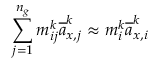Convert formula to latex. <formula><loc_0><loc_0><loc_500><loc_500>\sum _ { j = 1 } ^ { n _ { g } } m _ { i j } ^ { k } \overline { a } _ { x , j } ^ { k } \approx m _ { i } ^ { k } \overline { a } _ { x , i } ^ { k }</formula> 